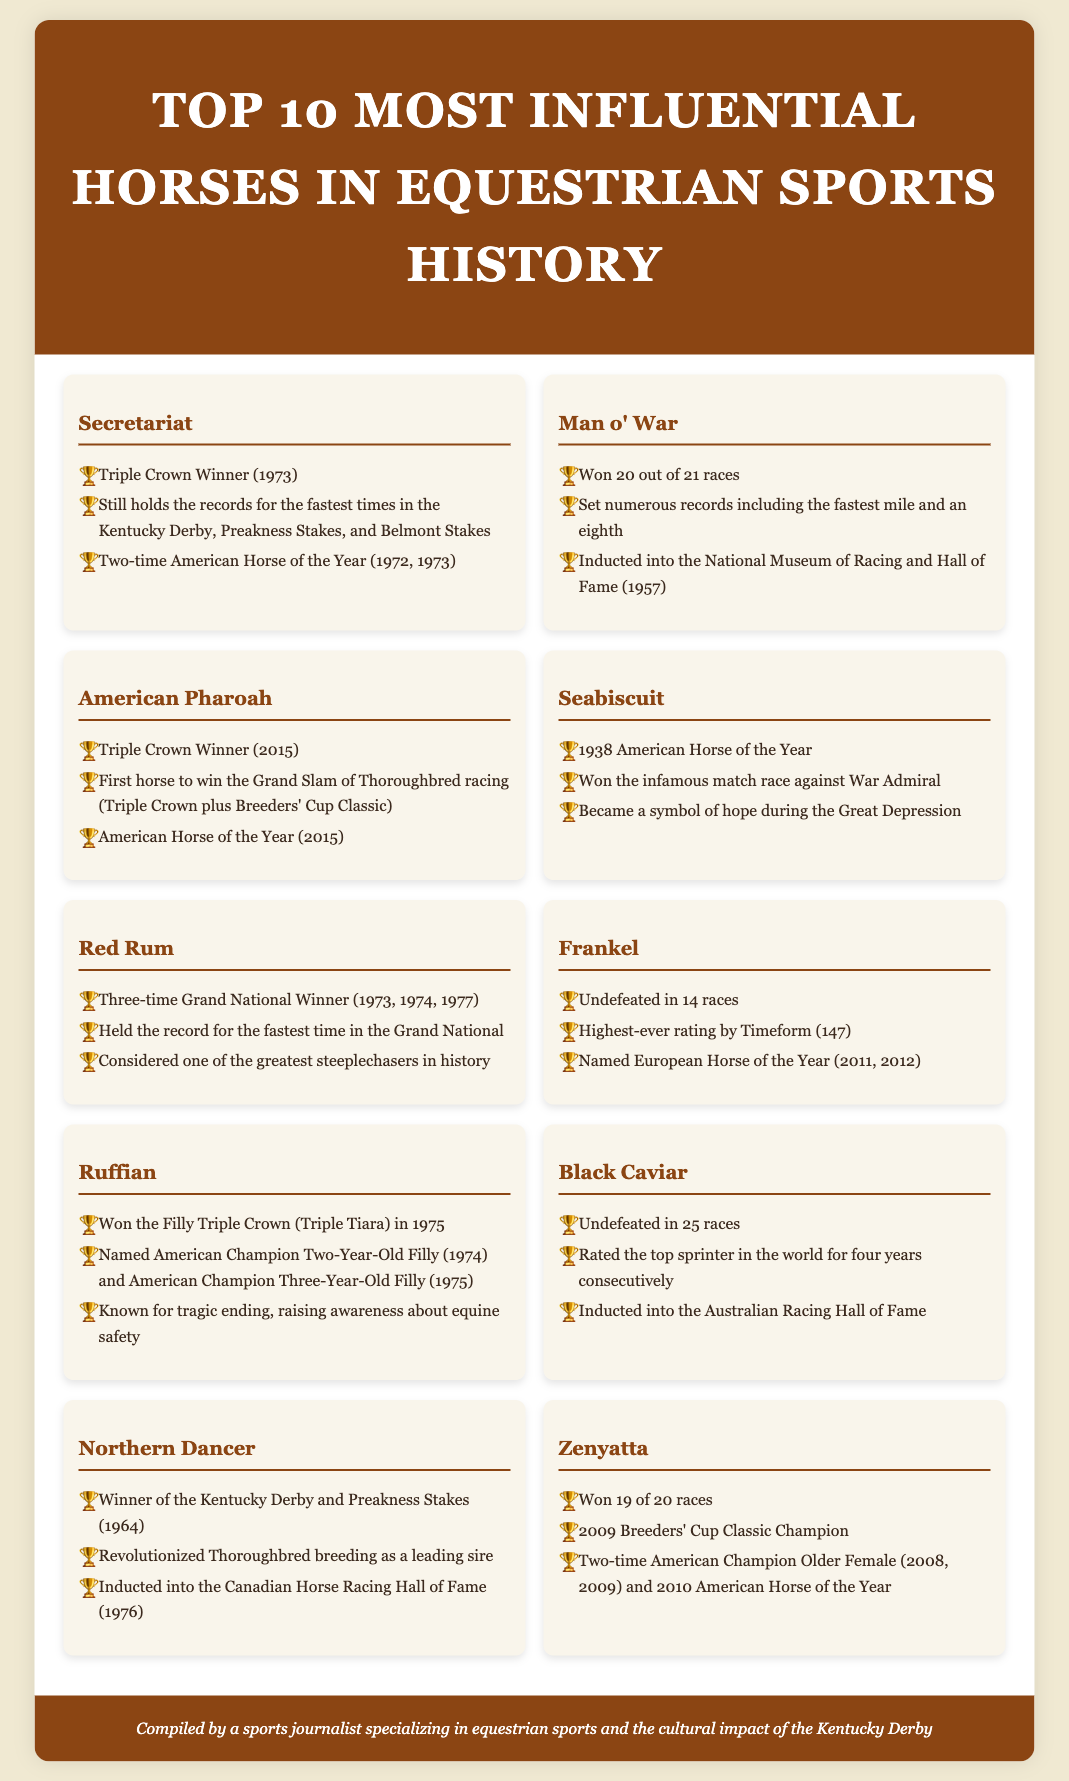What year did Secretariat win the Triple Crown? Secretariat won the Triple Crown in 1973.
Answer: 1973 How many races did Man o' War win? Man o' War won 20 out of 21 races, showcasing his dominance in racing.
Answer: 20 Which horse was the first to win the Grand Slam of Thoroughbred racing? American Pharoah was the first horse to achieve this feat in 2015.
Answer: American Pharoah How many times did Red Rum win the Grand National? Red Rum won the Grand National three times, highlighting his exceptional talent in steeplechasing.
Answer: Three times Which horse is known for having an undefeated record of 25 races? Black Caviar is recognized for her impressive undefeated streak of 25 races in total.
Answer: Black Caviar Who won the infamous match race against War Admiral? Seabiscuit became famously known for winning this match race, which was significant during the Great Depression.
Answer: Seabiscuit What achievements did Ruffian accomplish in 1975? Ruffian won the Filly Triple Crown (Triple Tiara) in 1975, marking a historical achievement for fillies in racing.
Answer: Filly Triple Crown Which horse is noted for having the highest-ever rating by Timeform? Frankel was rated the highest by Timeform, achieving a rating of 147.
Answer: 147 What is the legacy of Northern Dancer in Thoroughbred breeding? Northern Dancer is recognized for revolutionizing Thoroughbred breeding as a leading sire.
Answer: Leading sire 